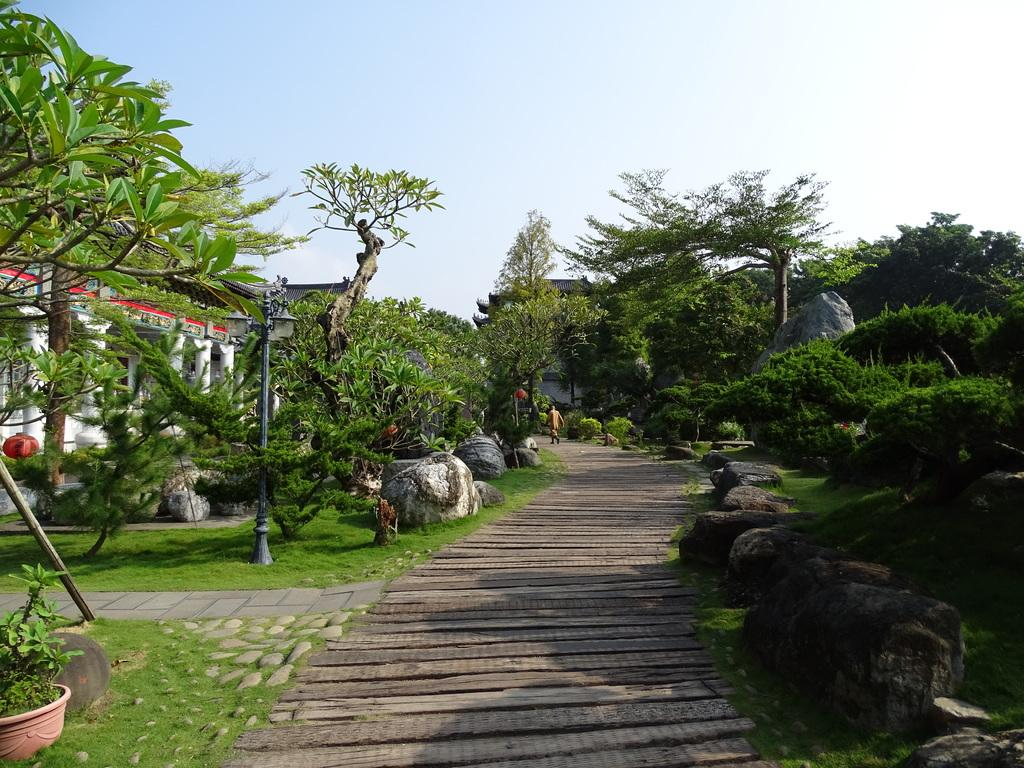What is the main feature in the middle of the image? There is a path in the middle of the image. What can be seen on both sides of the path? There are stones and trees on both sides of the path. Are there any structures visible in the image? Yes, there are buildings on both sides of the path. What else can be seen in the image? There is a plant pot in the image. What is the condition of the sky in the image? The sky is clear in the image. Can you hear a whistle in the image? There is no indication of a whistle in the image, as it is a still image and does not contain any sounds. Is there a van parked on the path in the image? There is no van present in the image; only a path, stones, trees, buildings, and a plant pot are visible. 